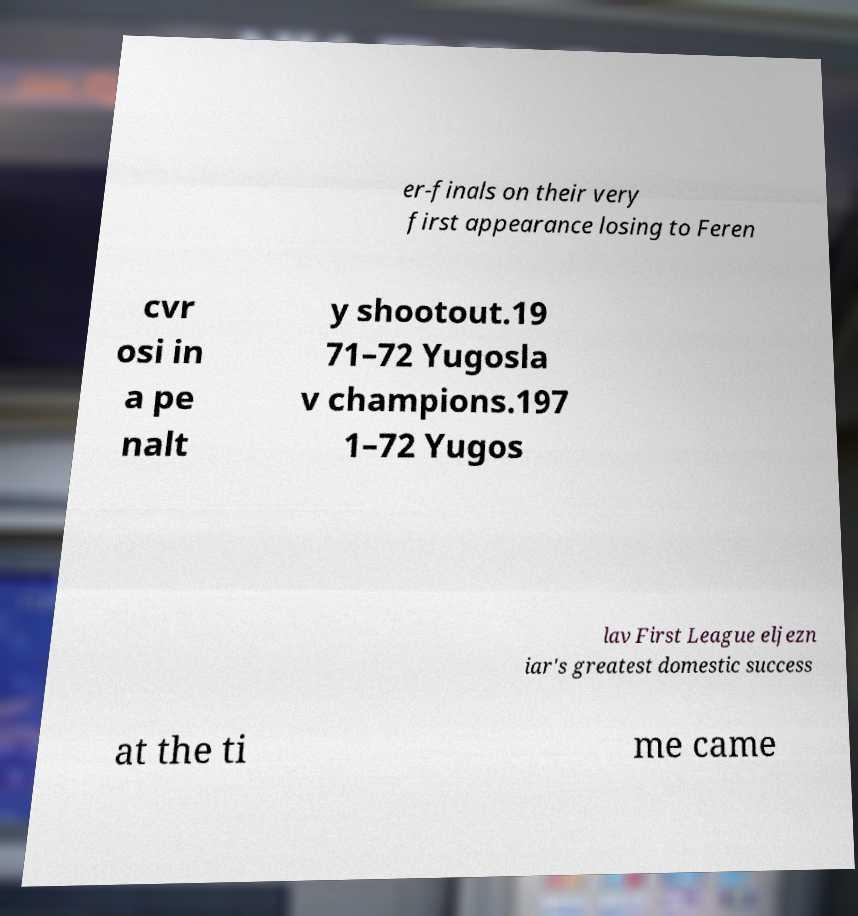Could you extract and type out the text from this image? er-finals on their very first appearance losing to Feren cvr osi in a pe nalt y shootout.19 71–72 Yugosla v champions.197 1–72 Yugos lav First League eljezn iar's greatest domestic success at the ti me came 